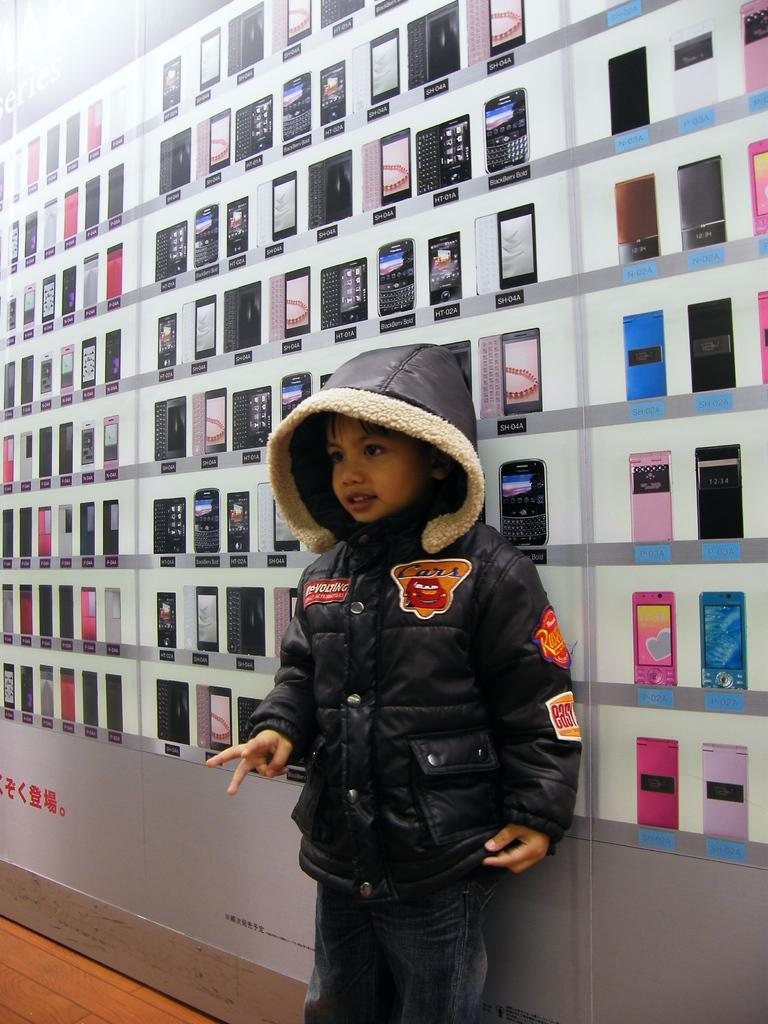Who is present in the image? There is a boy in the image. What is the boy doing in the image? The boy is standing. What is the boy wearing in the image? The boy is wearing a black jacket. What can be seen in the background of the image? There are printed phones in the background of the image. How many houses can be seen in the image? There are no houses present in the image. What type of building is visible in the image? There is no building visible in the image. 